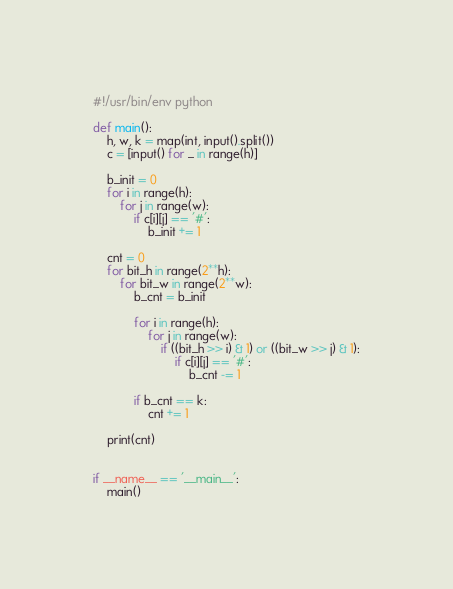<code> <loc_0><loc_0><loc_500><loc_500><_Python_>#!/usr/bin/env python

def main():
    h, w, k = map(int, input().split())
    c = [input() for _ in range(h)]

    b_init = 0
    for i in range(h):
        for j in range(w):
            if c[i][j] == '#':
                b_init += 1

    cnt = 0
    for bit_h in range(2**h):
        for bit_w in range(2**w):
            b_cnt = b_init

            for i in range(h):
                for j in range(w):
                    if ((bit_h >> i) & 1) or ((bit_w >> j) & 1):
                        if c[i][j] == '#':
                            b_cnt -= 1

            if b_cnt == k:
                cnt += 1

    print(cnt)


if __name__ == '__main__':
    main()
</code> 